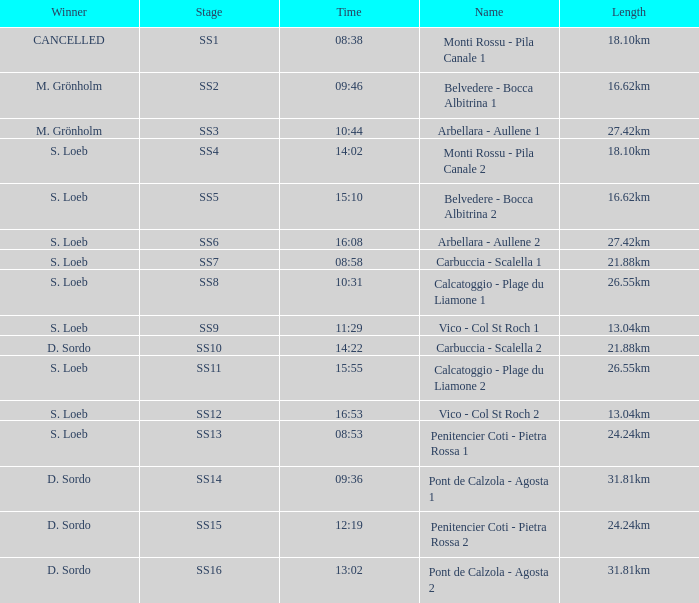What is the Name of the stage with a Length of 16.62km and Time of 15:10? Belvedere - Bocca Albitrina 2. 